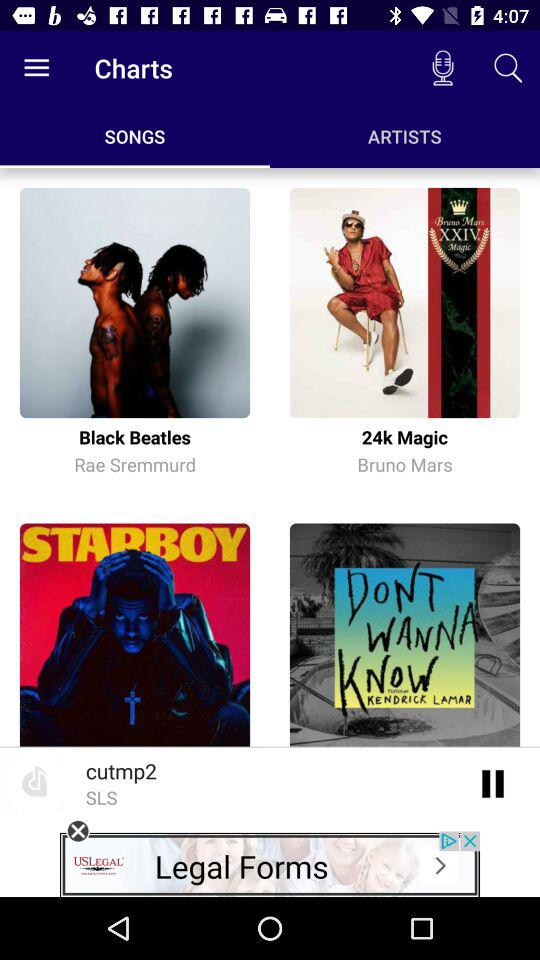Who is the composer of the song 24k Magic? The composer is Bruno Mars. 